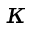Convert formula to latex. <formula><loc_0><loc_0><loc_500><loc_500>\kappa</formula> 